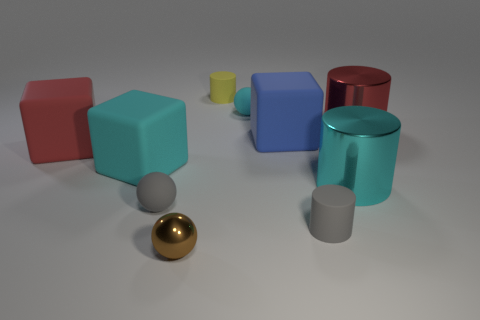Subtract 1 cylinders. How many cylinders are left? 3 Subtract all blue balls. Subtract all brown cylinders. How many balls are left? 3 Subtract all cylinders. How many objects are left? 6 Add 1 large red matte blocks. How many large red matte blocks are left? 2 Add 4 small green rubber balls. How many small green rubber balls exist? 4 Subtract 0 purple cylinders. How many objects are left? 10 Subtract all big purple shiny things. Subtract all big cylinders. How many objects are left? 8 